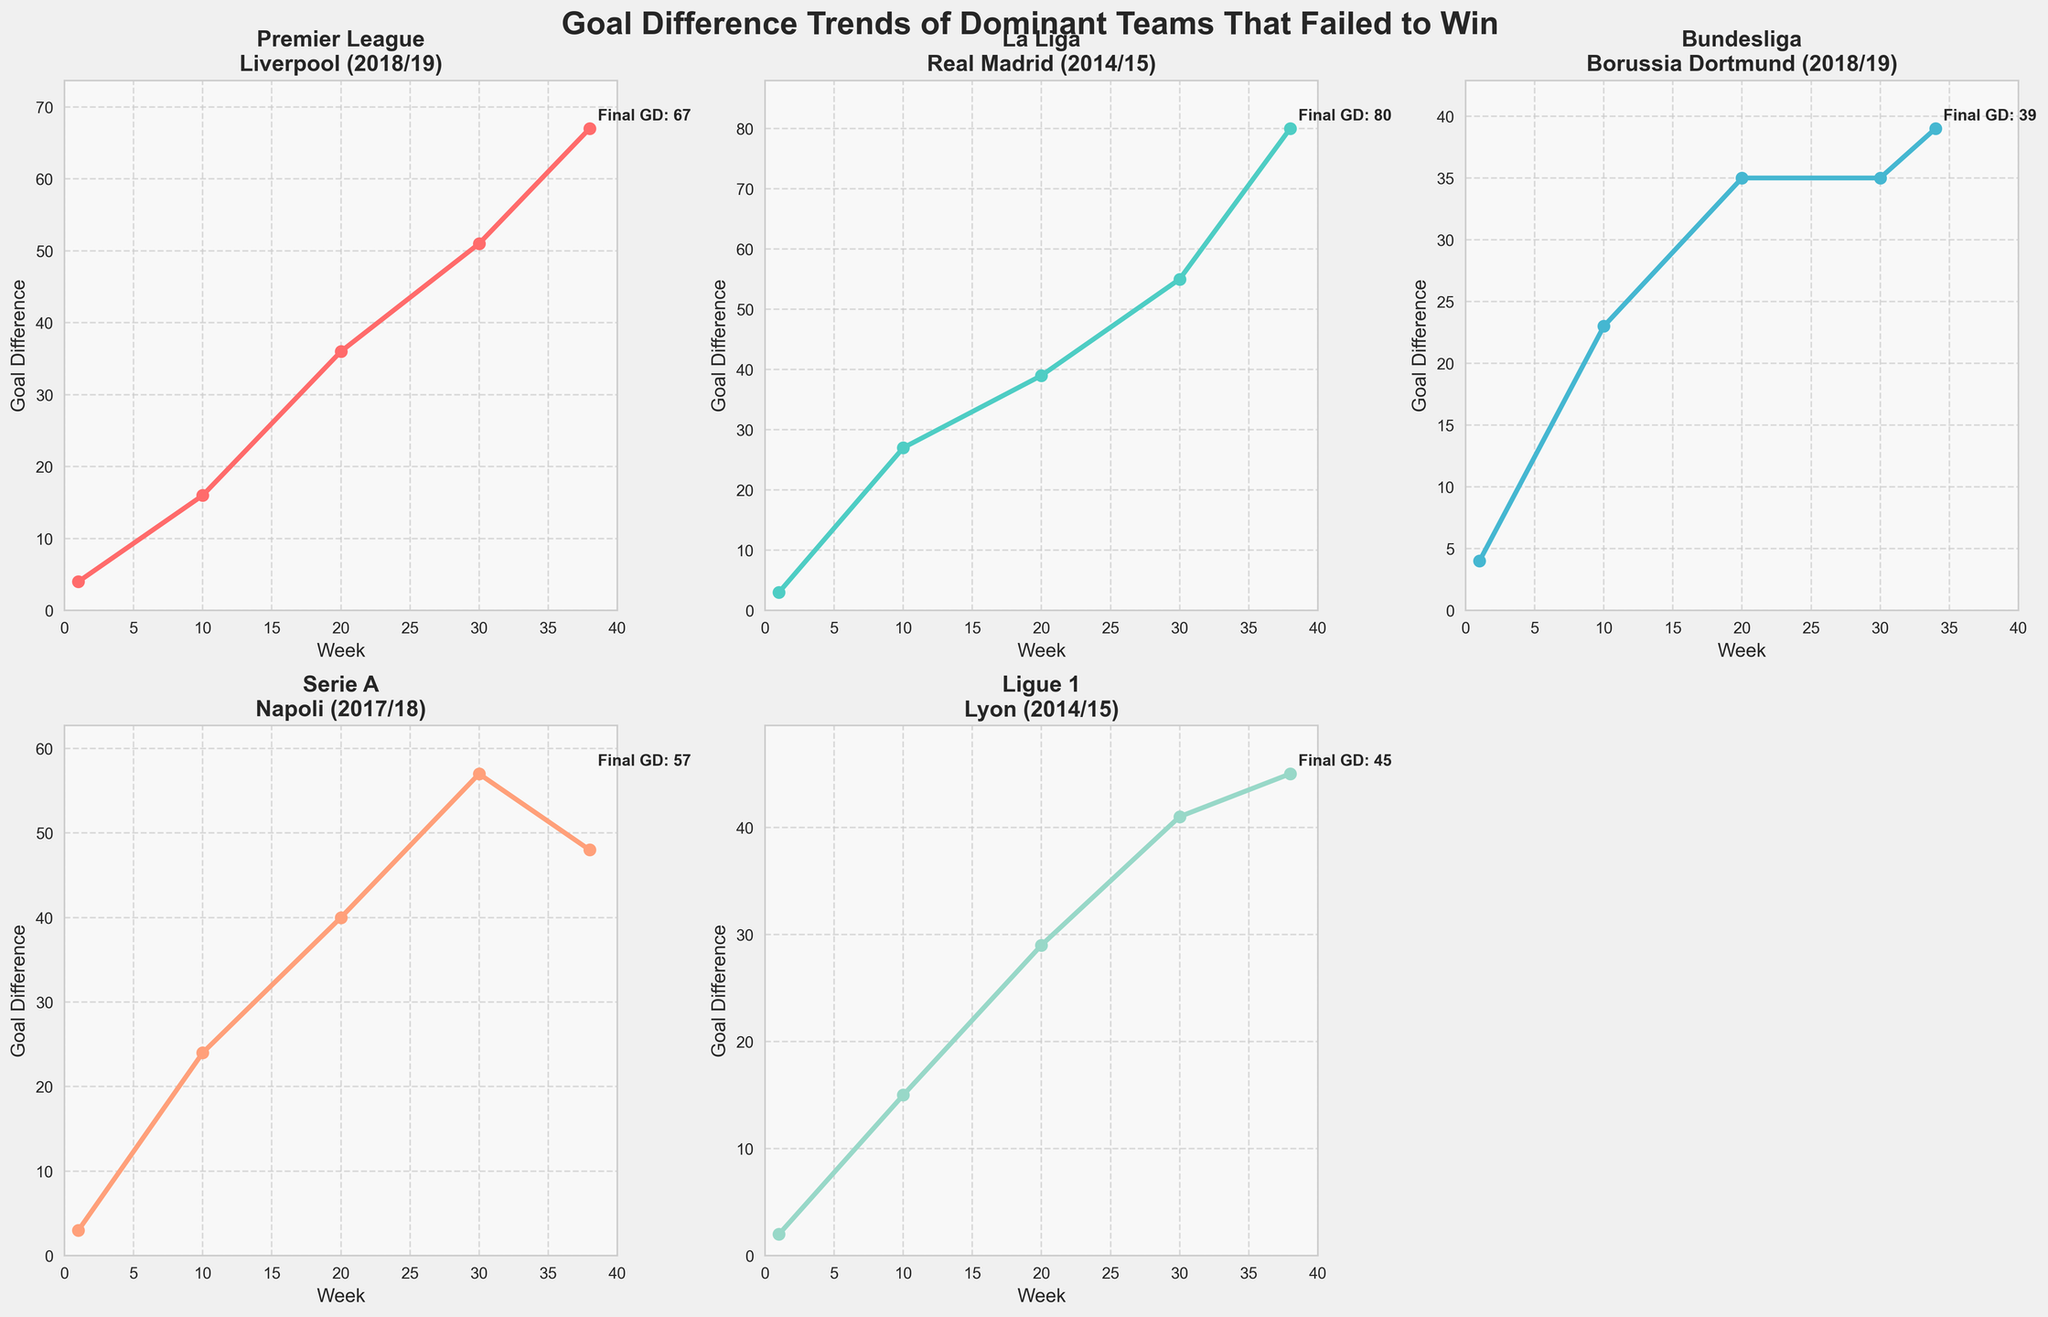Which team has the highest final goal difference? By looking at the final goal difference annotated on each subplot, we can see the maximum values. Liverpool has 67 in 2018/19 Premier League, Real Madrid has 80 in 2014/15 La Liga, Borussia Dortmund has 39 in 2018/19 Bundesliga, Napoli has 48 in 2017/18 Serie A, and Lyon has 45 in 2014/15 Ligue 1. Therefore, Real Madrid has the highest final goal difference with 80.
Answer: Real Madrid Which team showed a decrease in goal difference towards the end of the season? Observing the trend lines, Borussia Dortmund's goal difference stays flat at 35 from week 20 to week 30 before rising slightly to 39 by the end of the season. However, Napoli's goal difference decreases from 57 in week 30 to 48 in week 38 of the 2017/18 Serie A season.
Answer: Napoli If you averaged the final goal differences across all teams, what would it be? The final goal differences are 67 for Liverpool, 80 for Real Madrid, 39 for Borussia Dortmund, 48 for Napoli, and 45 for Lyon. The average is calculated as (67 + 80 + 39 + 48 + 45) / 5 = 279 / 5 = 55.8.
Answer: 55.8 Which team's goal difference increased the most from week 1 to week 10? To determine the team with the highest increase in goal difference from week 1 to week 10, calculate the difference for each team. Liverpool: 16 - 4 = 12, Real Madrid: 27 - 3 = 24, Borussia Dortmund: 23 - 4 = 19, Napoli: 24 - 3 = 21, Lyon: 15 - 2 = 13. Therefore, Real Madrid increased the most with 24.
Answer: Real Madrid Which team has the least variation in its goal difference trend over the season? Assess the visual trend lines for consistency. Borussia Dortmund's goal difference rises sharply then levels off with minimal change in the latter part of the season, compared to other teams showing more dynamic changes.
Answer: Borussia Dortmund Compare the change in goal difference of Liverpool and Napoli between week 10 and week 20. Liverpool's goal difference changes from 16 in week 10 to 36 in week 20, a change of 36 - 16 = 20. Napoli's goal difference changes from 24 in week 10 to 40 in week 20, a change of 40 - 24 = 16. Therefore, Liverpool's increase (20) is more than Napoli's (16).
Answer: Liverpool Which league's team ended with a goal difference closest to 50? Napoli ended with a goal difference of 48 in the 2017/18 Serie A season, which is closest to 50 compared to the other teams' final goal differences.
Answer: Serie A At which week did Lyon's goal difference reach the highest value, and what was it? Observing the trend line for Lyon, the highest goal difference is at week 30 with a value of 41 before slightly decreasing by week 38.
Answer: Week 30, 41 Which team experienced the largest single-week jump in goal difference? To identify, observe the steepest slope within any one-week period. Real Madrid in La Liga 2014/15 saw a sharp rise from week 1 to week 10, going from 3 to 27, a jump of 24 in a single week, indicating high scoring relative to other teams.
Answer: Real Madrid Which two teams had the same goal difference at the end of their respective leagues? Examining the final values, Borussia Dortmund in Bundesliga and Lyon in Ligue 1 ended with very close final goal differences of 39 and 45 respectively; however, no teams have exactly the same final goal difference.
Answer: None 